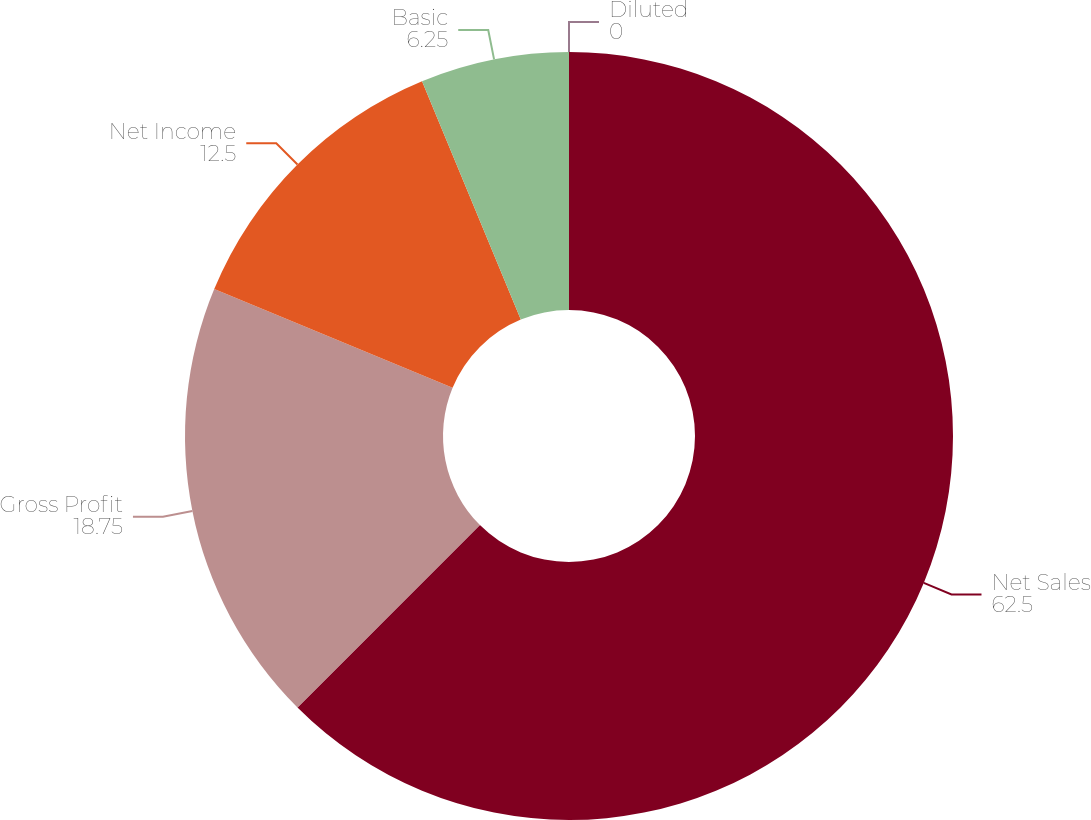<chart> <loc_0><loc_0><loc_500><loc_500><pie_chart><fcel>Net Sales<fcel>Gross Profit<fcel>Net Income<fcel>Basic<fcel>Diluted<nl><fcel>62.5%<fcel>18.75%<fcel>12.5%<fcel>6.25%<fcel>0.0%<nl></chart> 